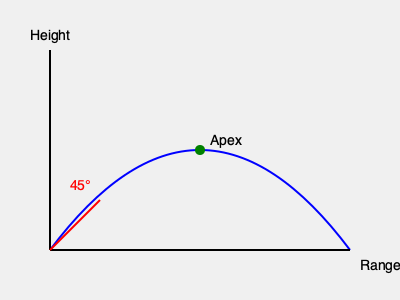As a former ROTC cadet, you're tasked with predicting the trajectory of a mortar round during a field exercise. Given an initial velocity of 50 m/s and a launch angle of 45°, what is the maximum height reached by the projectile? (Assume $g = 9.8$ m/s²) To find the maximum height of the projectile, we'll follow these steps:

1) The vertical component of the initial velocity is:
   $v_y = v_0 \sin \theta = 50 \cdot \sin 45° = 50 \cdot \frac{\sqrt{2}}{2} \approx 35.36$ m/s

2) The time to reach the maximum height is when the vertical velocity becomes zero:
   $t_{max} = \frac{v_y}{g} = \frac{35.36}{9.8} \approx 3.61$ seconds

3) The maximum height can be calculated using the equation:
   $h_{max} = v_y t_{max} - \frac{1}{2}gt_{max}^2$

4) Substituting the values:
   $h_{max} = 35.36 \cdot 3.61 - \frac{1}{2} \cdot 9.8 \cdot 3.61^2$
   $h_{max} = 127.65 - 63.82 = 63.83$ meters

Therefore, the maximum height reached by the projectile is approximately 63.83 meters.
Answer: 63.83 meters 